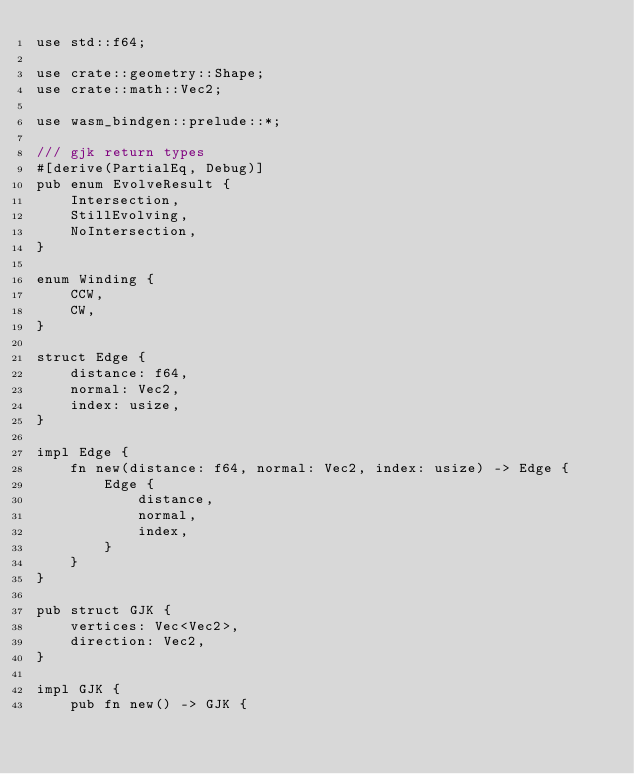<code> <loc_0><loc_0><loc_500><loc_500><_Rust_>use std::f64;

use crate::geometry::Shape;
use crate::math::Vec2;

use wasm_bindgen::prelude::*;

/// gjk return types
#[derive(PartialEq, Debug)]
pub enum EvolveResult {
    Intersection,
    StillEvolving,
    NoIntersection,
}

enum Winding {
    CCW,
    CW,
}

struct Edge {
    distance: f64,
    normal: Vec2,
    index: usize,
}

impl Edge {
    fn new(distance: f64, normal: Vec2, index: usize) -> Edge {
        Edge {
            distance,
            normal,
            index,
        }
    }
}

pub struct GJK {
    vertices: Vec<Vec2>,
    direction: Vec2,
}

impl GJK {
    pub fn new() -> GJK {</code> 